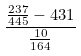<formula> <loc_0><loc_0><loc_500><loc_500>\frac { \frac { 2 3 7 } { 4 4 5 } - 4 3 1 } { \frac { 1 0 } { 1 6 4 } }</formula> 